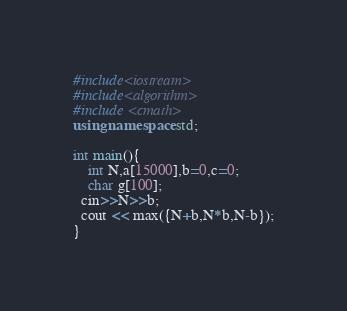<code> <loc_0><loc_0><loc_500><loc_500><_C++_>#include<iostream>
#include<algorithm>
#include <cmath>
using namespace std;
 
int main(){
    int N,a[15000],b=0,c=0;
    char g[100];
  cin>>N>>b;
  cout << max({N+b,N*b,N-b});
}</code> 